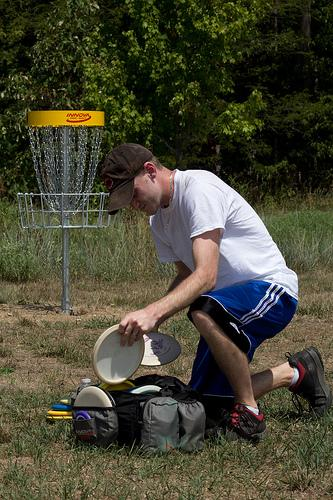Mention the primary object a person is holding in the image and its color. The man is holding a white frisbee in his hand. Briefly describe an activity that the person in the image appears to be doing. The man is kneeling on the ground, holding a white frisbee. Comment on the state of the grass in the image and any visible patches. The grass appears brown and green, with several patchy areas. Write about the type of footwear the person is wearing, including its color. The man is wearing black shoes with red accents. Describe a piece of sports equipment visible in the image and its purpose. A sport disc catcher is present in the background for frisbee practice. What is the type and color of headwear the man is wearing in the image? The man is wearing a brown hat on his head. Mention the brand of the bag and the visible logo in the image. The bag is by Innova, with the Innova logo visible on it. What type of green vegetation can be seen in the background of the image? Tall bushy green trees are visible in the background. List any objects visible in the bag that belongs to the person in the image. Items in the bag include a water bottle and yellow and blue frisbees. Describe the type of outfit and its colors that the man is wearing in the image. The man is dressed in blue shorts with black trim and white socks. 